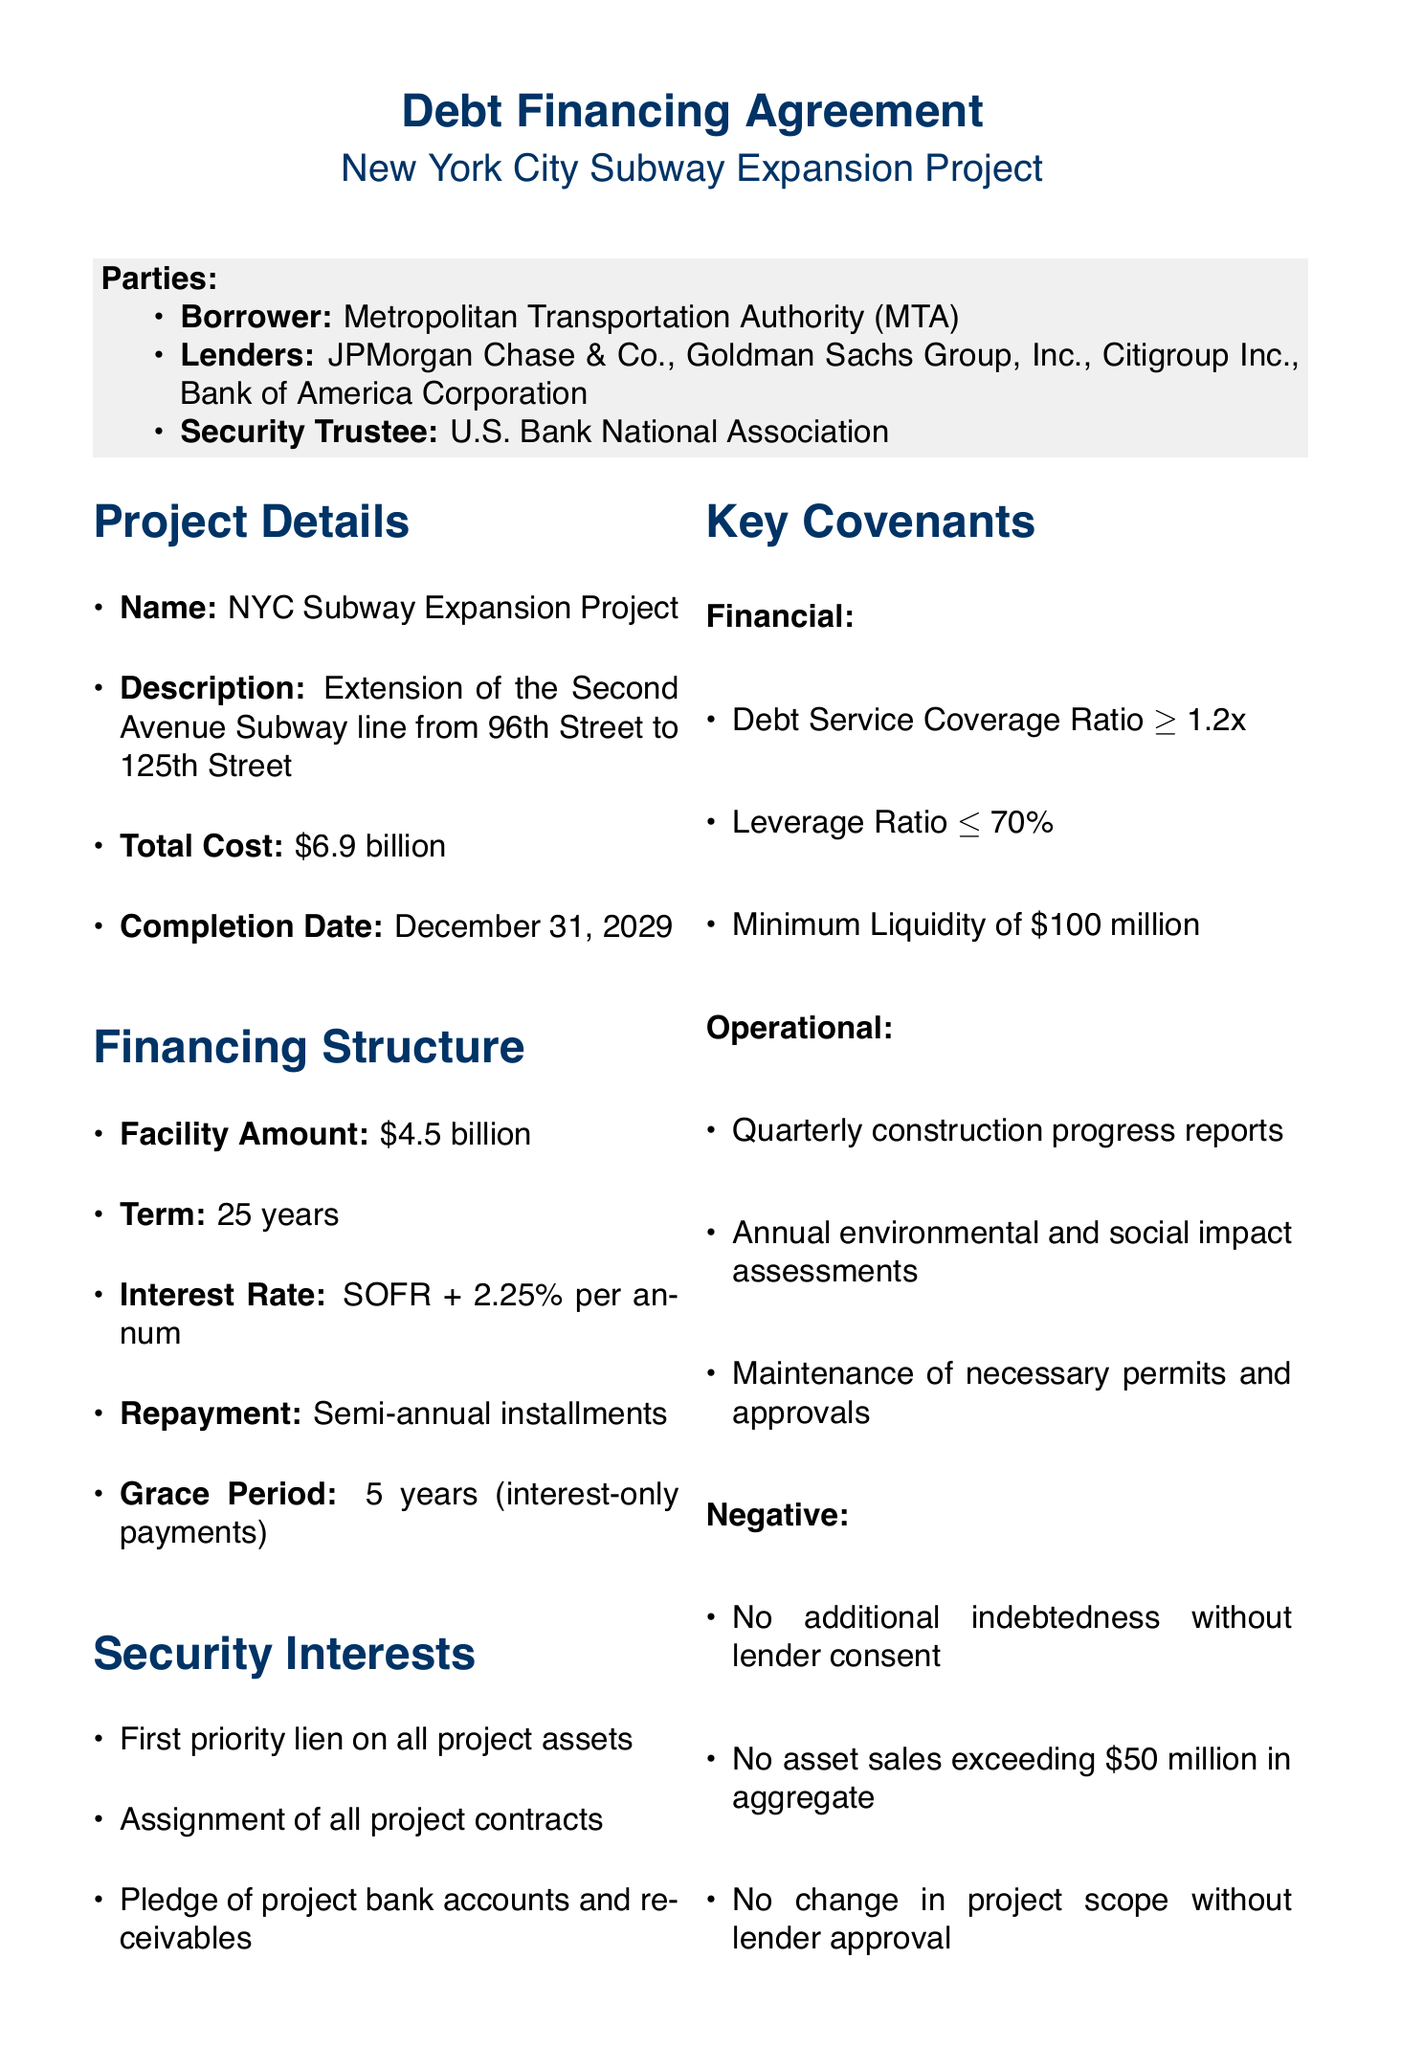What is the facility amount? The facility amount is specified in the financing structure section of the document, which is $4.5 billion.
Answer: $4.5 billion Who is the borrower? The borrower's identity is mentioned in the parties section as the Metropolitan Transportation Authority (MTA).
Answer: Metropolitan Transportation Authority (MTA) What is the completion date of the project? The completion date of the project is clearly stated in the project details section, which is December 31, 2029.
Answer: December 31, 2029 What is the Debt Service Coverage Ratio requirement? The Debt Service Coverage Ratio is outlined in the covenants section, which states it must be at least 1.2x.
Answer: 1.2x How long is the term of the financing agreement? The term can be found in the financing structure section where it states that it is for 25 years.
Answer: 25 years What is the interest rate for the financing? The interest rate is specified in the financing structure section, given as SOFR + 2.25% per annum.
Answer: SOFR + 2.25% per annum What are the events of default? Events of default are identified in the respective section and include items like failure to pay principal or interest.
Answer: Failure to pay principal or interest What governing law applies to this agreement? The governing law is stated at the end of the document in the legal framework section as the laws of the State of New York.
Answer: Laws of the State of New York What is the pledge collateralized? The pledge collateral in the security interests section includes project bank accounts and receivables, indicating what secures the debt.
Answer: Project bank accounts and receivables 